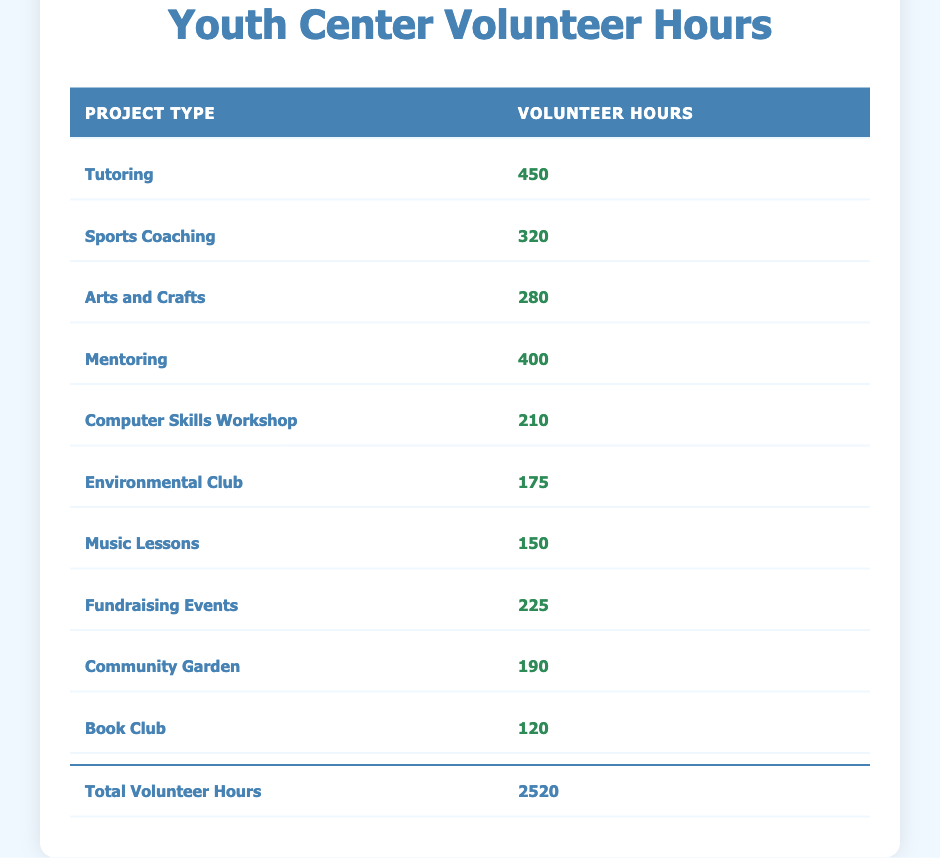What is the project type with the highest volunteer hours? The table lists the project types along with the corresponding volunteer hours. By examining the values, we find that "Tutoring" has 450 volunteer hours, which is the highest among all listed projects.
Answer: Tutoring What is the total number of volunteer hours logged for all projects combined? At the bottom of the table, there is a total row that summarizes the volunteer hours. The total listed is 2520, which represents the sum of all individual project hours.
Answer: 2520 How many more hours were logged in "Mentoring" compared to "Music Lessons"? The volunteer hours for "Mentoring" is 400 and for "Music Lessons" is 150. To find the difference, we subtract 150 from 400, resulting in 250.
Answer: 250 Is the number of volunteer hours for "Environmental Club" greater than that of "Computer Skills Workshop"? "Environmental Club" has 175 volunteer hours, while "Computer Skills Workshop" has 210 hours. Since 175 is less than 210, the statement is false.
Answer: No What is the average number of volunteer hours across all project types? To find the average, we sum all volunteer hours (2520) and divide by the number of projects (10): 2520/10 = 252. Therefore, the average is 252.
Answer: 252 Which project types logged less than 200 volunteer hours? Scanning through the table, "Environmental Club" (175), "Music Lessons" (150), and "Book Club" (120) are the only project types with less than 200 hours.
Answer: Environmental Club, Music Lessons, Book Club What percentage of the total volunteer hours does "Sports Coaching" represent? "Sports Coaching" has 320 volunteer hours. To find the percentage, divide 320 by the total hours (2520) and multiply by 100: (320/2520) * 100 ≈ 12.7%.
Answer: Approximately 12.7% Which project type has the least number of volunteer hours? Reviewing the listed data, "Book Club" has the lowest volunteer hours at 120 when compared to all other project types.
Answer: Book Club 